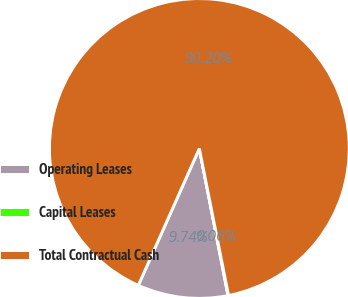Convert chart to OTSL. <chart><loc_0><loc_0><loc_500><loc_500><pie_chart><fcel>Operating Leases<fcel>Capital Leases<fcel>Total Contractual Cash<nl><fcel>9.74%<fcel>0.06%<fcel>90.19%<nl></chart> 